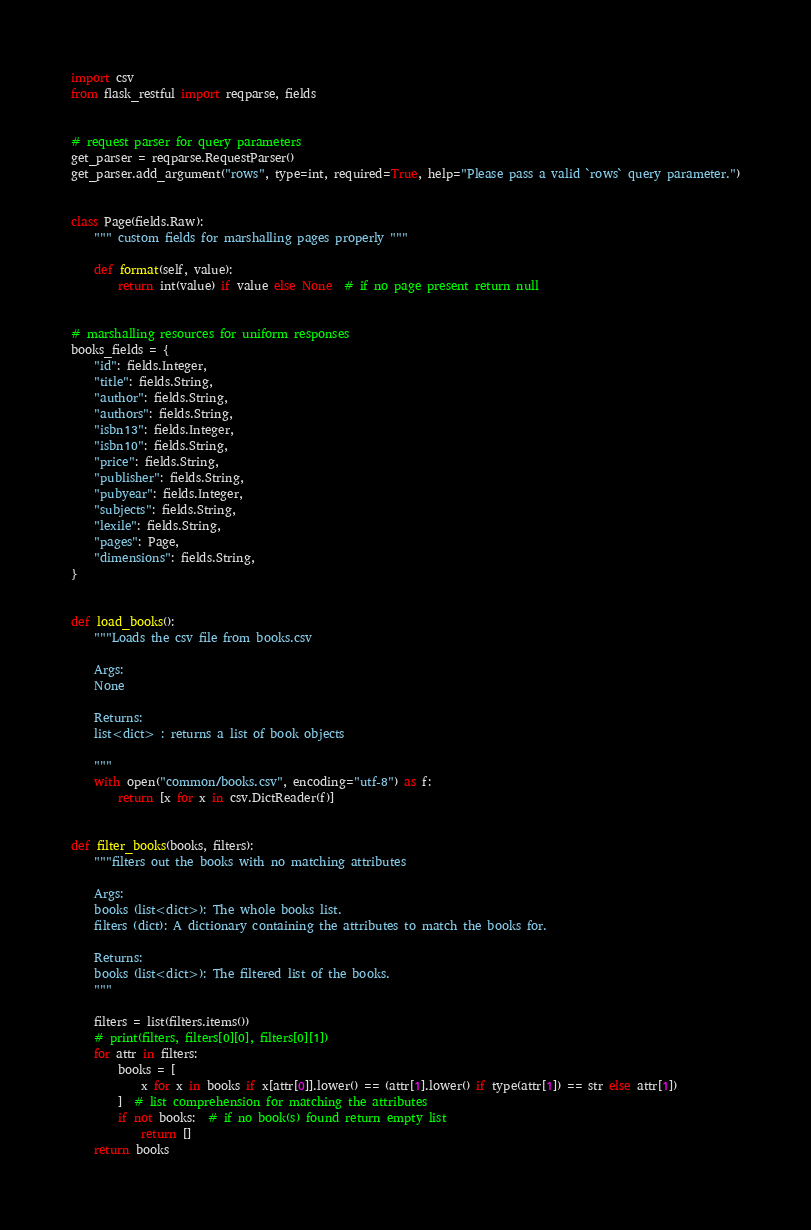<code> <loc_0><loc_0><loc_500><loc_500><_Python_>import csv
from flask_restful import reqparse, fields


# request parser for query parameters
get_parser = reqparse.RequestParser()
get_parser.add_argument("rows", type=int, required=True, help="Please pass a valid `rows` query parameter.")


class Page(fields.Raw):
    """ custom fields for marshalling pages properly """

    def format(self, value):
        return int(value) if value else None  # if no page present return null


# marshalling resources for uniform responses
books_fields = {
    "id": fields.Integer,
    "title": fields.String,
    "author": fields.String,
    "authors": fields.String,
    "isbn13": fields.Integer,
    "isbn10": fields.String,
    "price": fields.String,
    "publisher": fields.String,
    "pubyear": fields.Integer,
    "subjects": fields.String,
    "lexile": fields.String,
    "pages": Page,
    "dimensions": fields.String,
}


def load_books():
    """Loads the csv file from books.csv

    Args:
    None

    Returns:
    list<dict> : returns a list of book objects

    """
    with open("common/books.csv", encoding="utf-8") as f:
        return [x for x in csv.DictReader(f)]


def filter_books(books, filters):
    """filters out the books with no matching attributes

    Args:
    books (list<dict>): The whole books list.
    filters (dict): A dictionary containing the attributes to match the books for.

    Returns:
    books (list<dict>): The filtered list of the books.
    """

    filters = list(filters.items())
    # print(filters, filters[0][0], filters[0][1])
    for attr in filters:
        books = [
            x for x in books if x[attr[0]].lower() == (attr[1].lower() if type(attr[1]) == str else attr[1])
        ]  # list comprehension for matching the attributes
        if not books:  # if no book(s) found return empty list
            return []
    return books
</code> 